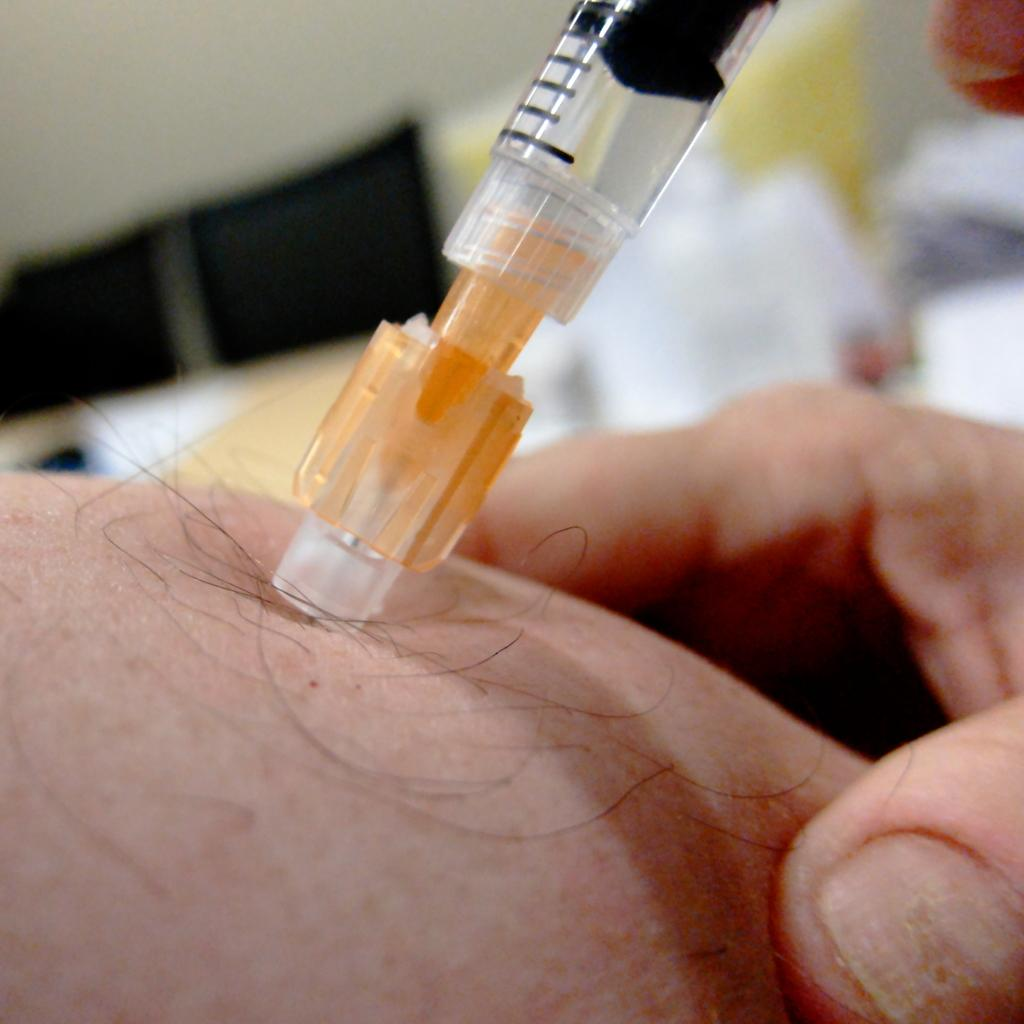What is the main subject of the image? The main subject of the image is an injection. Can you describe any other elements in the image? Yes, there is a person's hand in the image. What can be observed about the background of the image? The background of the image is blurry. How many boys are present in the image? There is no boy present in the image; it features an injection and a person's hand. What type of process is being performed with the scissors in the image? There are no scissors present in the image, so no such process can be observed. 